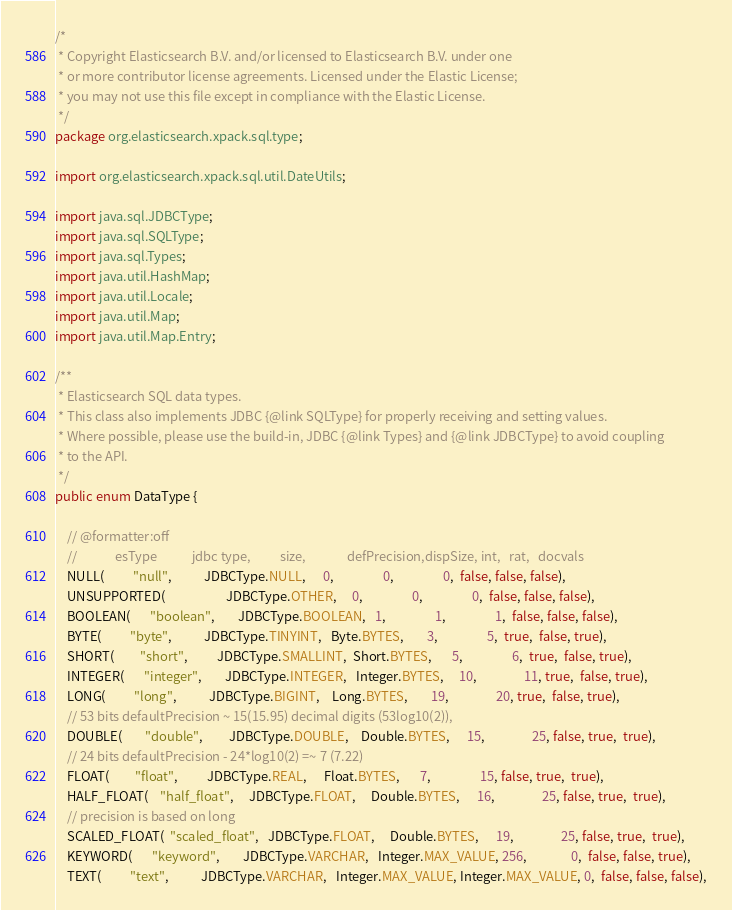<code> <loc_0><loc_0><loc_500><loc_500><_Java_>/*
 * Copyright Elasticsearch B.V. and/or licensed to Elasticsearch B.V. under one
 * or more contributor license agreements. Licensed under the Elastic License;
 * you may not use this file except in compliance with the Elastic License.
 */
package org.elasticsearch.xpack.sql.type;

import org.elasticsearch.xpack.sql.util.DateUtils;

import java.sql.JDBCType;
import java.sql.SQLType;
import java.sql.Types;
import java.util.HashMap;
import java.util.Locale;
import java.util.Map;
import java.util.Map.Entry;

/**
 * Elasticsearch SQL data types.
 * This class also implements JDBC {@link SQLType} for properly receiving and setting values.
 * Where possible, please use the build-in, JDBC {@link Types} and {@link JDBCType} to avoid coupling
 * to the API.
 */
public enum DataType {

    // @formatter:off
    //             esType            jdbc type,          size,              defPrecision,dispSize, int,   rat,   docvals
    NULL(          "null",           JDBCType.NULL,      0,                 0,                 0,  false, false, false),
    UNSUPPORTED(                     JDBCType.OTHER,     0,                 0,                 0,  false, false, false),
    BOOLEAN(       "boolean",        JDBCType.BOOLEAN,   1,                 1,                 1,  false, false, false),
    BYTE(          "byte",           JDBCType.TINYINT,   Byte.BYTES,        3,                 5,  true,  false, true),
    SHORT(         "short",          JDBCType.SMALLINT,  Short.BYTES,       5,                 6,  true,  false, true),
    INTEGER(       "integer",        JDBCType.INTEGER,   Integer.BYTES,     10,                11, true,  false, true),
    LONG(          "long",           JDBCType.BIGINT,    Long.BYTES,        19,                20, true,  false, true),
    // 53 bits defaultPrecision ~ 15(15.95) decimal digits (53log10(2)),
    DOUBLE(        "double",         JDBCType.DOUBLE,    Double.BYTES,      15,                25, false, true,  true),
    // 24 bits defaultPrecision - 24*log10(2) =~ 7 (7.22)
    FLOAT(         "float",          JDBCType.REAL,      Float.BYTES,       7,                 15, false, true,  true),
    HALF_FLOAT(    "half_float",     JDBCType.FLOAT,     Double.BYTES,      16,                25, false, true,  true),
    // precision is based on long
    SCALED_FLOAT(  "scaled_float",   JDBCType.FLOAT,     Double.BYTES,      19,                25, false, true,  true),
    KEYWORD(       "keyword",        JDBCType.VARCHAR,   Integer.MAX_VALUE, 256,               0,  false, false, true),
    TEXT(          "text",           JDBCType.VARCHAR,   Integer.MAX_VALUE, Integer.MAX_VALUE, 0,  false, false, false),</code> 